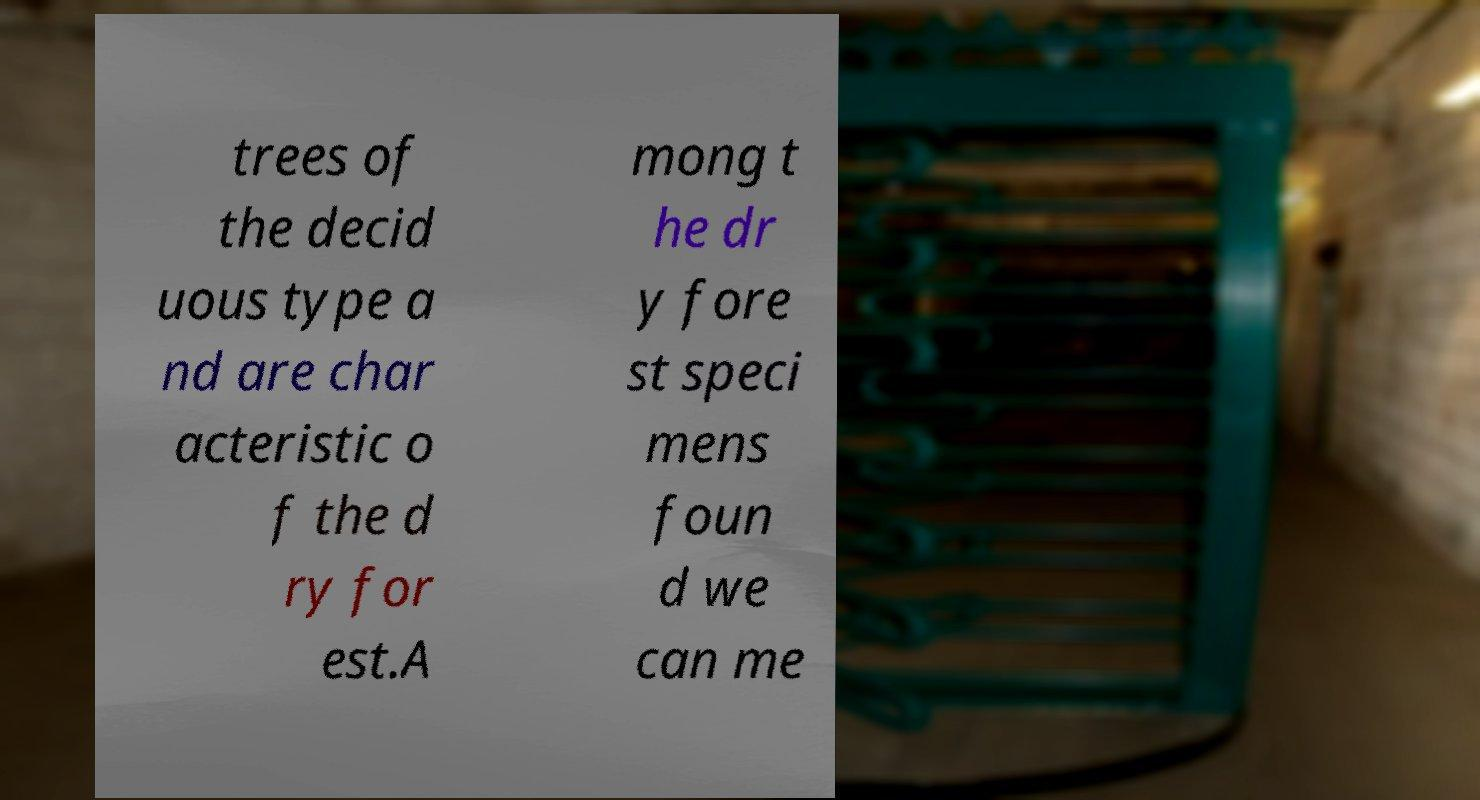There's text embedded in this image that I need extracted. Can you transcribe it verbatim? trees of the decid uous type a nd are char acteristic o f the d ry for est.A mong t he dr y fore st speci mens foun d we can me 